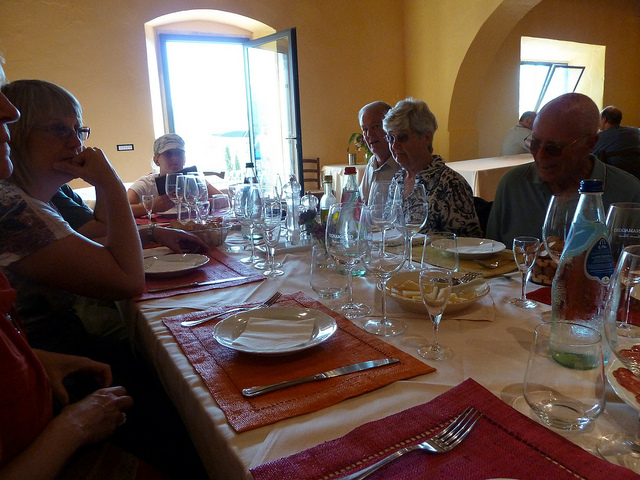<image>What pattern is the tablecloth? It's ambiguous what pattern the tablecloth is. It could be a solid or plain pattern. What pattern is the tablecloth? I don't know what pattern the tablecloth is. It can be solid, red orange, plain, or white. 